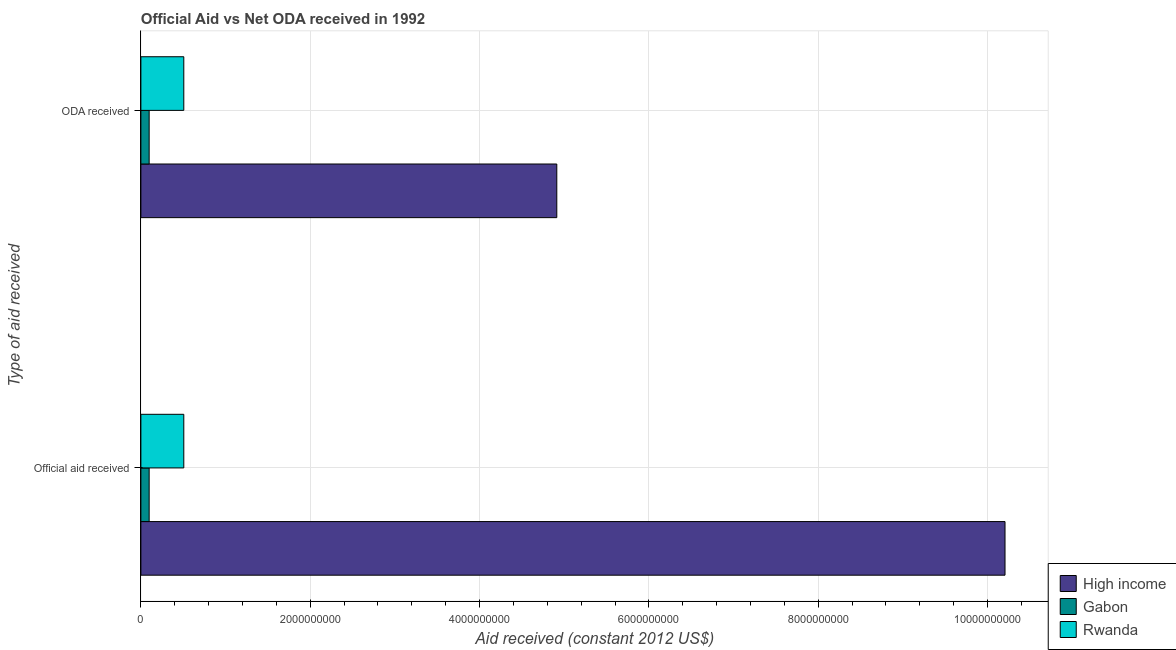Are the number of bars per tick equal to the number of legend labels?
Give a very brief answer. Yes. Are the number of bars on each tick of the Y-axis equal?
Ensure brevity in your answer.  Yes. What is the label of the 1st group of bars from the top?
Offer a terse response. ODA received. What is the oda received in Rwanda?
Make the answer very short. 5.07e+08. Across all countries, what is the maximum official aid received?
Give a very brief answer. 1.02e+1. Across all countries, what is the minimum official aid received?
Give a very brief answer. 9.76e+07. In which country was the official aid received maximum?
Ensure brevity in your answer.  High income. In which country was the official aid received minimum?
Your answer should be compact. Gabon. What is the total oda received in the graph?
Offer a very short reply. 5.52e+09. What is the difference between the official aid received in Rwanda and that in Gabon?
Keep it short and to the point. 4.09e+08. What is the difference between the official aid received in Gabon and the oda received in Rwanda?
Your answer should be compact. -4.09e+08. What is the average oda received per country?
Offer a terse response. 1.84e+09. What is the ratio of the official aid received in Rwanda to that in High income?
Your answer should be very brief. 0.05. What does the 2nd bar from the top in ODA received represents?
Your response must be concise. Gabon. What does the 1st bar from the bottom in ODA received represents?
Provide a succinct answer. High income. How many bars are there?
Your answer should be very brief. 6. How many countries are there in the graph?
Provide a succinct answer. 3. How are the legend labels stacked?
Keep it short and to the point. Vertical. What is the title of the graph?
Offer a terse response. Official Aid vs Net ODA received in 1992 . What is the label or title of the X-axis?
Offer a terse response. Aid received (constant 2012 US$). What is the label or title of the Y-axis?
Provide a short and direct response. Type of aid received. What is the Aid received (constant 2012 US$) in High income in Official aid received?
Offer a terse response. 1.02e+1. What is the Aid received (constant 2012 US$) of Gabon in Official aid received?
Your answer should be very brief. 9.76e+07. What is the Aid received (constant 2012 US$) of Rwanda in Official aid received?
Your response must be concise. 5.07e+08. What is the Aid received (constant 2012 US$) in High income in ODA received?
Offer a very short reply. 4.91e+09. What is the Aid received (constant 2012 US$) in Gabon in ODA received?
Offer a very short reply. 9.76e+07. What is the Aid received (constant 2012 US$) of Rwanda in ODA received?
Ensure brevity in your answer.  5.07e+08. Across all Type of aid received, what is the maximum Aid received (constant 2012 US$) in High income?
Keep it short and to the point. 1.02e+1. Across all Type of aid received, what is the maximum Aid received (constant 2012 US$) of Gabon?
Offer a very short reply. 9.76e+07. Across all Type of aid received, what is the maximum Aid received (constant 2012 US$) in Rwanda?
Your answer should be very brief. 5.07e+08. Across all Type of aid received, what is the minimum Aid received (constant 2012 US$) in High income?
Your response must be concise. 4.91e+09. Across all Type of aid received, what is the minimum Aid received (constant 2012 US$) of Gabon?
Make the answer very short. 9.76e+07. Across all Type of aid received, what is the minimum Aid received (constant 2012 US$) of Rwanda?
Your response must be concise. 5.07e+08. What is the total Aid received (constant 2012 US$) in High income in the graph?
Your answer should be compact. 1.51e+1. What is the total Aid received (constant 2012 US$) in Gabon in the graph?
Offer a terse response. 1.95e+08. What is the total Aid received (constant 2012 US$) of Rwanda in the graph?
Offer a terse response. 1.01e+09. What is the difference between the Aid received (constant 2012 US$) in High income in Official aid received and that in ODA received?
Offer a terse response. 5.29e+09. What is the difference between the Aid received (constant 2012 US$) of Gabon in Official aid received and that in ODA received?
Offer a terse response. 0. What is the difference between the Aid received (constant 2012 US$) in Rwanda in Official aid received and that in ODA received?
Your answer should be very brief. 0. What is the difference between the Aid received (constant 2012 US$) in High income in Official aid received and the Aid received (constant 2012 US$) in Gabon in ODA received?
Provide a succinct answer. 1.01e+1. What is the difference between the Aid received (constant 2012 US$) of High income in Official aid received and the Aid received (constant 2012 US$) of Rwanda in ODA received?
Provide a succinct answer. 9.70e+09. What is the difference between the Aid received (constant 2012 US$) of Gabon in Official aid received and the Aid received (constant 2012 US$) of Rwanda in ODA received?
Ensure brevity in your answer.  -4.09e+08. What is the average Aid received (constant 2012 US$) of High income per Type of aid received?
Your answer should be compact. 7.56e+09. What is the average Aid received (constant 2012 US$) of Gabon per Type of aid received?
Offer a terse response. 9.76e+07. What is the average Aid received (constant 2012 US$) of Rwanda per Type of aid received?
Keep it short and to the point. 5.07e+08. What is the difference between the Aid received (constant 2012 US$) in High income and Aid received (constant 2012 US$) in Gabon in Official aid received?
Give a very brief answer. 1.01e+1. What is the difference between the Aid received (constant 2012 US$) of High income and Aid received (constant 2012 US$) of Rwanda in Official aid received?
Ensure brevity in your answer.  9.70e+09. What is the difference between the Aid received (constant 2012 US$) in Gabon and Aid received (constant 2012 US$) in Rwanda in Official aid received?
Ensure brevity in your answer.  -4.09e+08. What is the difference between the Aid received (constant 2012 US$) in High income and Aid received (constant 2012 US$) in Gabon in ODA received?
Provide a short and direct response. 4.81e+09. What is the difference between the Aid received (constant 2012 US$) in High income and Aid received (constant 2012 US$) in Rwanda in ODA received?
Give a very brief answer. 4.41e+09. What is the difference between the Aid received (constant 2012 US$) of Gabon and Aid received (constant 2012 US$) of Rwanda in ODA received?
Provide a succinct answer. -4.09e+08. What is the ratio of the Aid received (constant 2012 US$) in High income in Official aid received to that in ODA received?
Provide a short and direct response. 2.08. What is the ratio of the Aid received (constant 2012 US$) of Gabon in Official aid received to that in ODA received?
Provide a succinct answer. 1. What is the difference between the highest and the second highest Aid received (constant 2012 US$) in High income?
Ensure brevity in your answer.  5.29e+09. What is the difference between the highest and the lowest Aid received (constant 2012 US$) in High income?
Ensure brevity in your answer.  5.29e+09. What is the difference between the highest and the lowest Aid received (constant 2012 US$) of Rwanda?
Your answer should be very brief. 0. 